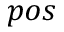<formula> <loc_0><loc_0><loc_500><loc_500>p o s</formula> 